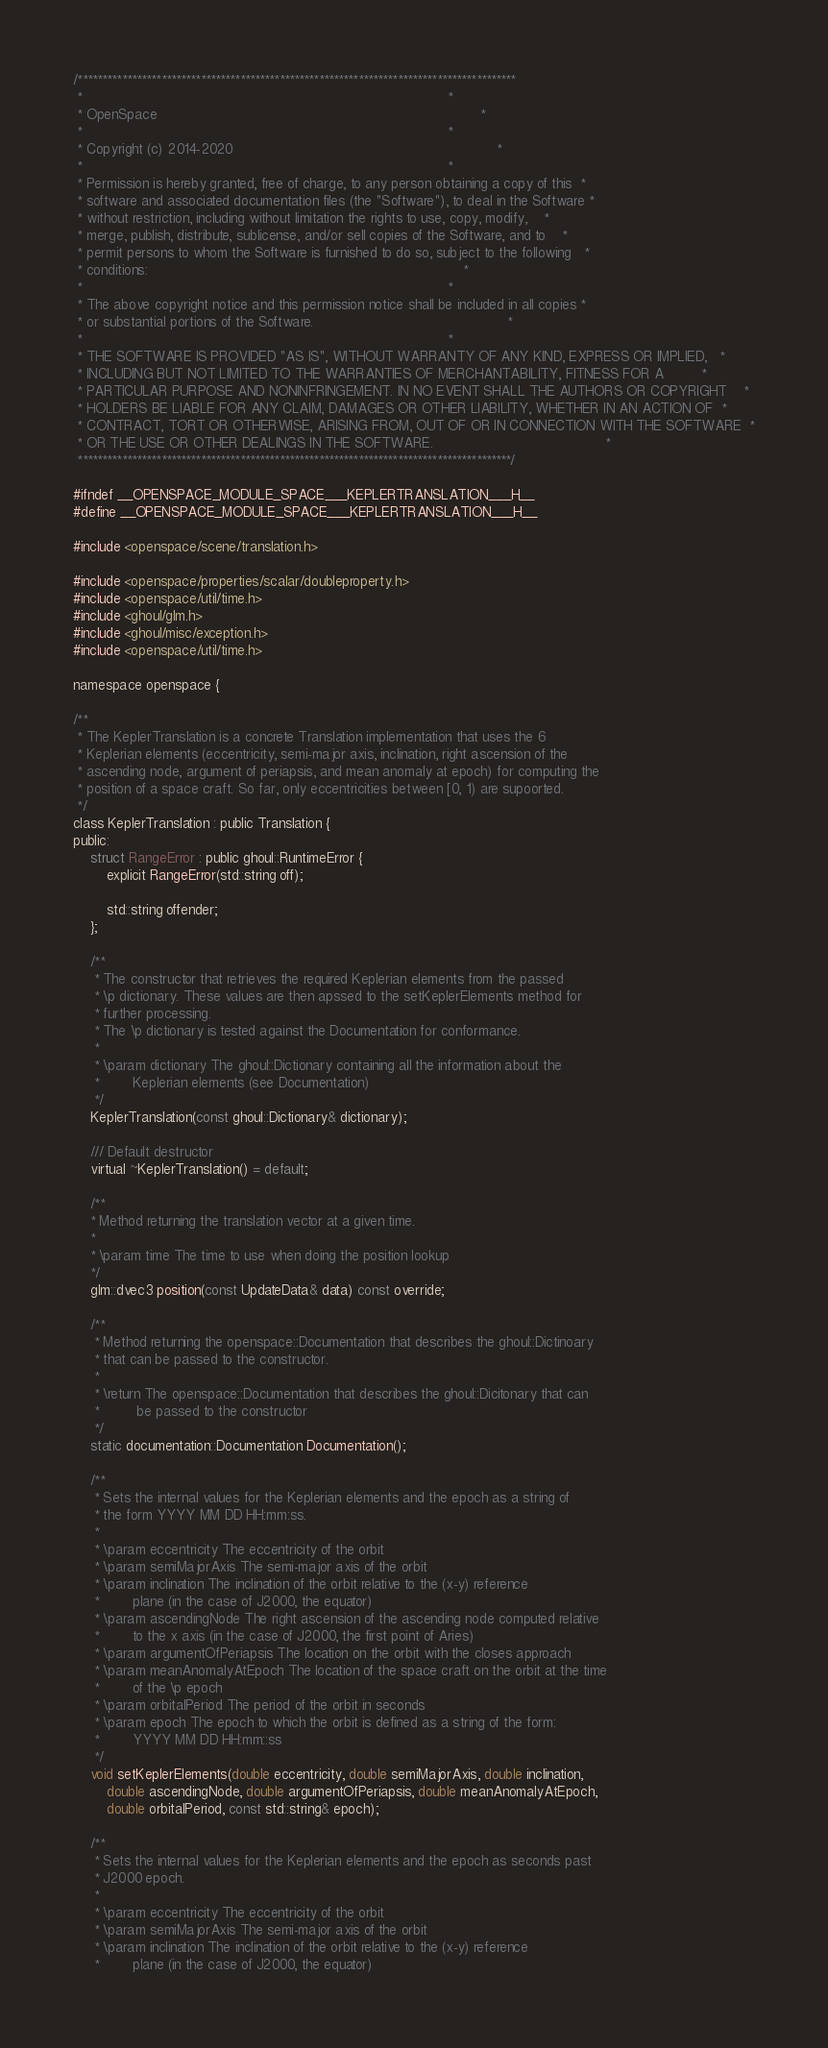<code> <loc_0><loc_0><loc_500><loc_500><_C_>/*****************************************************************************************
 *                                                                                       *
 * OpenSpace                                                                             *
 *                                                                                       *
 * Copyright (c) 2014-2020                                                               *
 *                                                                                       *
 * Permission is hereby granted, free of charge, to any person obtaining a copy of this  *
 * software and associated documentation files (the "Software"), to deal in the Software *
 * without restriction, including without limitation the rights to use, copy, modify,    *
 * merge, publish, distribute, sublicense, and/or sell copies of the Software, and to    *
 * permit persons to whom the Software is furnished to do so, subject to the following   *
 * conditions:                                                                           *
 *                                                                                       *
 * The above copyright notice and this permission notice shall be included in all copies *
 * or substantial portions of the Software.                                              *
 *                                                                                       *
 * THE SOFTWARE IS PROVIDED "AS IS", WITHOUT WARRANTY OF ANY KIND, EXPRESS OR IMPLIED,   *
 * INCLUDING BUT NOT LIMITED TO THE WARRANTIES OF MERCHANTABILITY, FITNESS FOR A         *
 * PARTICULAR PURPOSE AND NONINFRINGEMENT. IN NO EVENT SHALL THE AUTHORS OR COPYRIGHT    *
 * HOLDERS BE LIABLE FOR ANY CLAIM, DAMAGES OR OTHER LIABILITY, WHETHER IN AN ACTION OF  *
 * CONTRACT, TORT OR OTHERWISE, ARISING FROM, OUT OF OR IN CONNECTION WITH THE SOFTWARE  *
 * OR THE USE OR OTHER DEALINGS IN THE SOFTWARE.                                         *
 ****************************************************************************************/

#ifndef __OPENSPACE_MODULE_SPACE___KEPLERTRANSLATION___H__
#define __OPENSPACE_MODULE_SPACE___KEPLERTRANSLATION___H__

#include <openspace/scene/translation.h>

#include <openspace/properties/scalar/doubleproperty.h>
#include <openspace/util/time.h>
#include <ghoul/glm.h>
#include <ghoul/misc/exception.h>
#include <openspace/util/time.h>

namespace openspace {

/**
 * The KeplerTranslation is a concrete Translation implementation that uses the 6
 * Keplerian elements (eccentricity, semi-major axis, inclination, right ascension of the
 * ascending node, argument of periapsis, and mean anomaly at epoch) for computing the
 * position of a space craft. So far, only eccentricities between [0, 1) are supoorted.
 */
class KeplerTranslation : public Translation {
public:
    struct RangeError : public ghoul::RuntimeError {
        explicit RangeError(std::string off);

        std::string offender;
    };

    /**
     * The constructor that retrieves the required Keplerian elements from the passed
     * \p dictionary. These values are then apssed to the setKeplerElements method for
     * further processing.
     * The \p dictionary is tested against the Documentation for conformance.
     *
     * \param dictionary The ghoul::Dictionary containing all the information about the
     *        Keplerian elements (see Documentation)
     */
    KeplerTranslation(const ghoul::Dictionary& dictionary);

    /// Default destructor
    virtual ~KeplerTranslation() = default;

    /**
    * Method returning the translation vector at a given time.
    *
    * \param time The time to use when doing the position lookup
    */
    glm::dvec3 position(const UpdateData& data) const override;

    /**
     * Method returning the openspace::Documentation that describes the ghoul::Dictinoary
     * that can be passed to the constructor.
     *
     * \return The openspace::Documentation that describes the ghoul::Dicitonary that can
     *         be passed to the constructor
     */
    static documentation::Documentation Documentation();

    /**
     * Sets the internal values for the Keplerian elements and the epoch as a string of
     * the form YYYY MM DD HH:mm:ss.
     *
     * \param eccentricity The eccentricity of the orbit
     * \param semiMajorAxis The semi-major axis of the orbit
     * \param inclination The inclination of the orbit relative to the (x-y) reference
     *        plane (in the case of J2000, the equator)
     * \param ascendingNode The right ascension of the ascending node computed relative
     *        to the x axis (in the case of J2000, the first point of Aries)
     * \param argumentOfPeriapsis The location on the orbit with the closes approach
     * \param meanAnomalyAtEpoch The location of the space craft on the orbit at the time
     *        of the \p epoch
     * \param orbitalPeriod The period of the orbit in seconds
     * \param epoch The epoch to which the orbit is defined as a string of the form:
     *        YYYY MM DD HH:mm::ss
     */
    void setKeplerElements(double eccentricity, double semiMajorAxis, double inclination,
        double ascendingNode, double argumentOfPeriapsis, double meanAnomalyAtEpoch,
        double orbitalPeriod, const std::string& epoch);

    /**
     * Sets the internal values for the Keplerian elements and the epoch as seconds past
     * J2000 epoch.
     *
     * \param eccentricity The eccentricity of the orbit
     * \param semiMajorAxis The semi-major axis of the orbit
     * \param inclination The inclination of the orbit relative to the (x-y) reference
     *        plane (in the case of J2000, the equator)</code> 